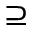<formula> <loc_0><loc_0><loc_500><loc_500>\supseteq</formula> 